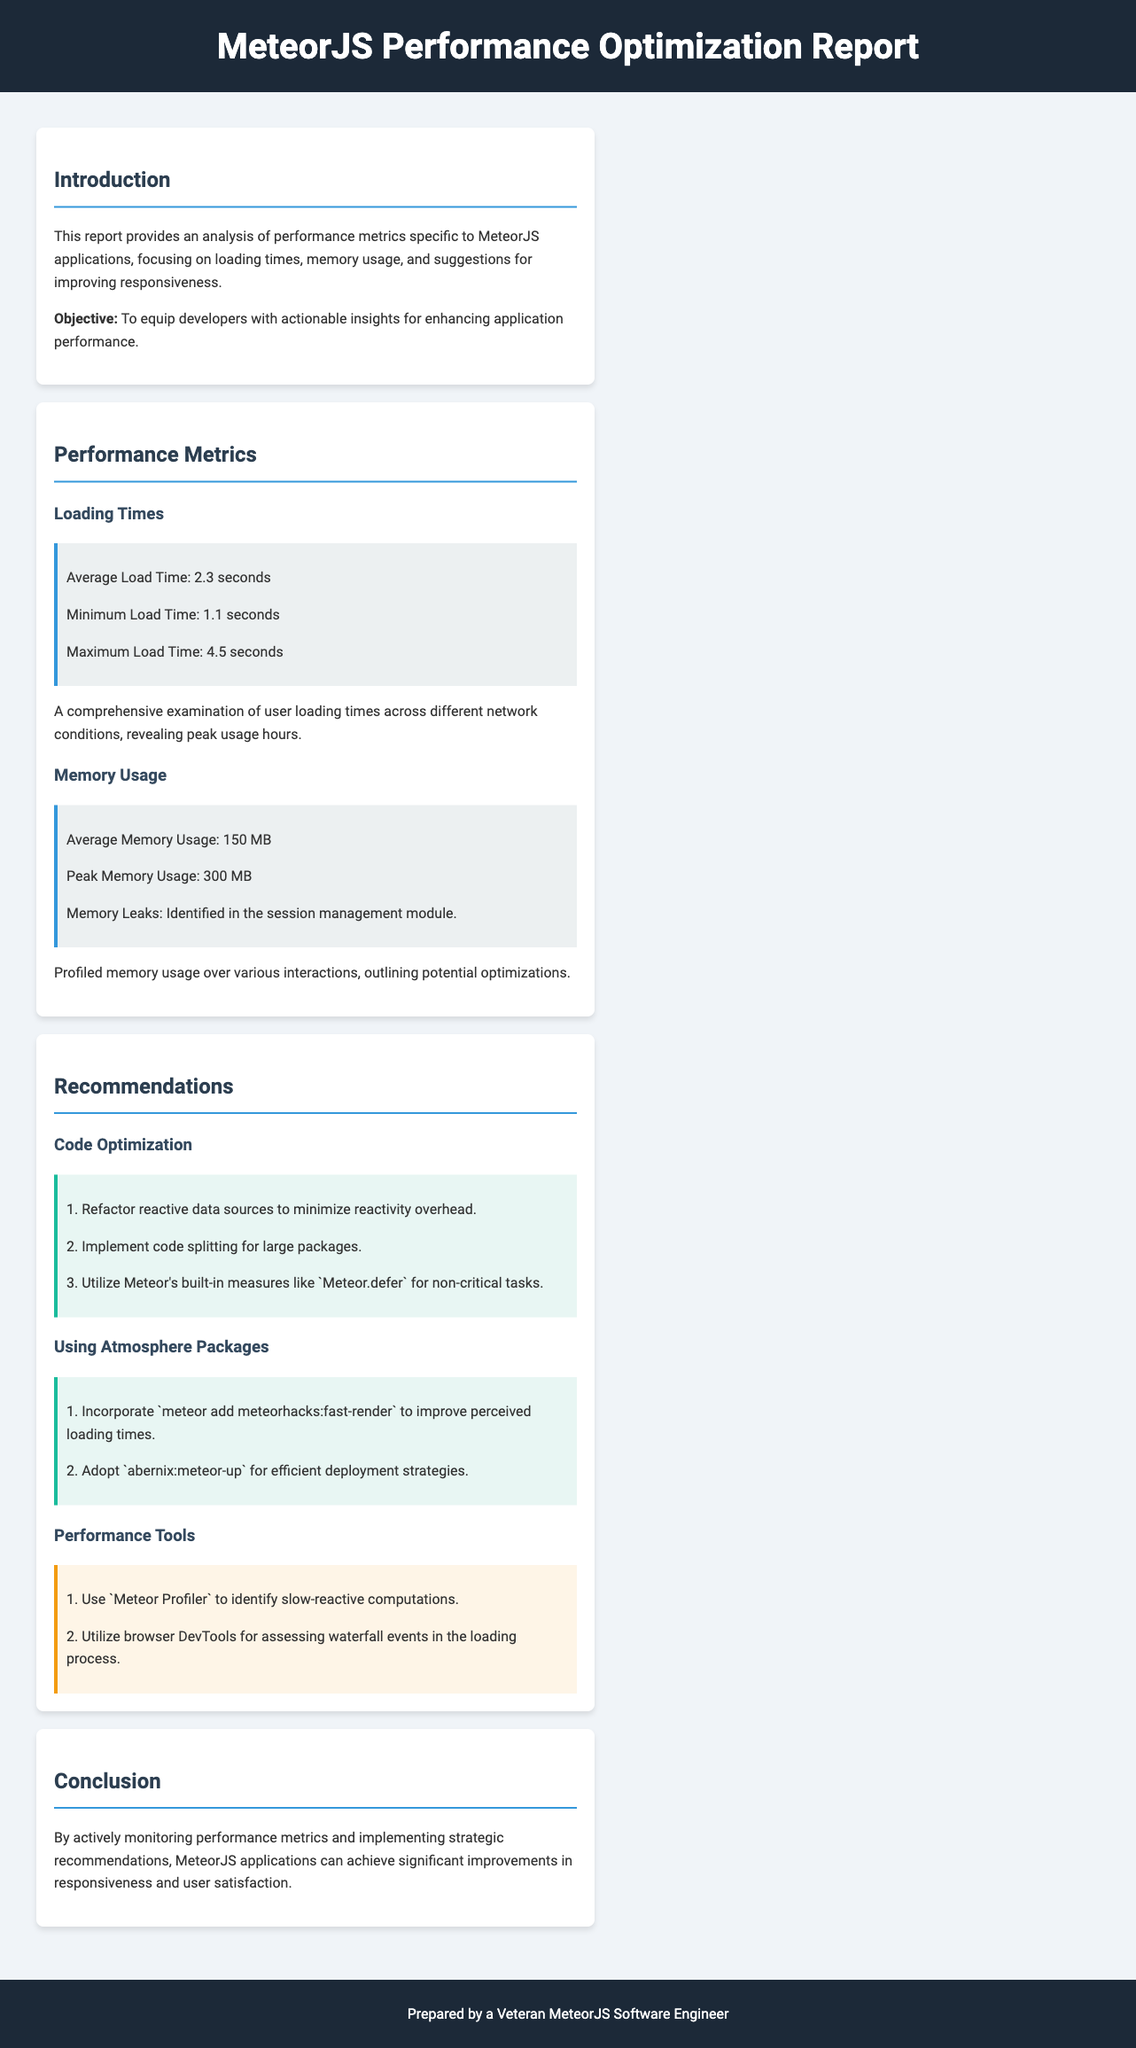What is the average load time? The average load time is specifically stated in the Performance Metrics section of the document.
Answer: 2.3 seconds What is the minimum load time recorded? The document lists the minimum load time in the Performance Metrics section, providing specific performance data.
Answer: 1.1 seconds What memory leaks were identified? The document clearly identifies the memory leaks as being in a specific module, which is mentioned in the Memory Usage subsection.
Answer: session management module How much is the peak memory usage? The peak memory usage is specified in the Performance Metrics section, detailing the memory consumption metrics assessed.
Answer: 300 MB What is one tool recommended for performance analysis? The document lists specific performance tools in the Recommendations section that aid in optimizing MeteorJS applications.
Answer: Meteor Profiler What is the objective of this report? The introductory section of the document outlines the goal of the report, clarifying its primary purpose for developers.
Answer: To equip developers with actionable insights for enhancing application performance How can code splitting help? Recommendations section mentions code splitting, which implies benefits for performance based on the context in the document.
Answer: Improve perceived loading times What is one recommendation for using Atmosphere packages? The Recommendations section lists specific packages and how they can enhance performance, capturing essential advice for developers.
Answer: meteorhacks:fast-render 